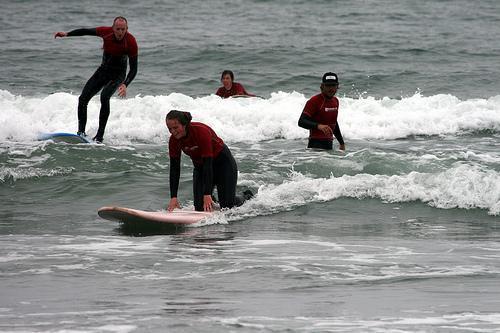How many people are in the water?
Give a very brief answer. 4. 